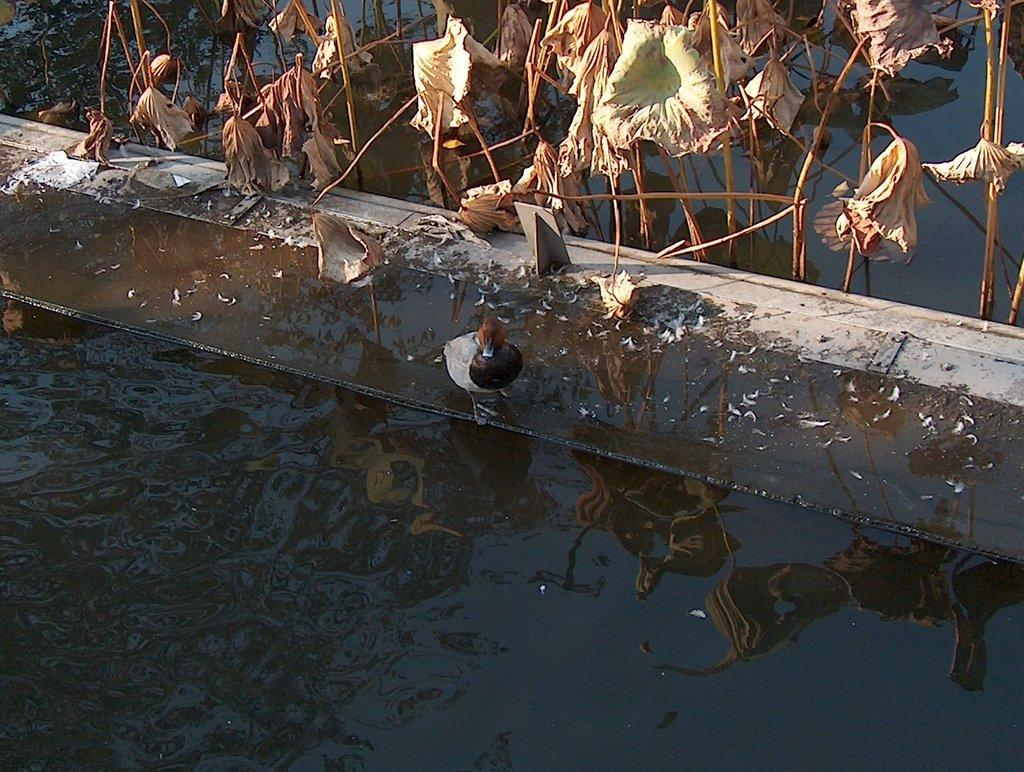What is the main feature of the image? There is water in the image. What structure is present on the water? There is a bridge on the water. What animal can be seen on the bridge? There is a duck on the bridge. What type of vegetation is near the bridge? There are plants near the bridge. What type of vegetable is growing on the bridge in the image? There are no vegetables present in the image; only plants are near the bridge. 